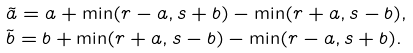<formula> <loc_0><loc_0><loc_500><loc_500>& \tilde { a } = a + \min ( r - a , s + b ) - \min ( r + a , s - b ) , \\ & \tilde { b } = b + \min ( r + a , s - b ) - \min ( r - a , s + b ) .</formula> 